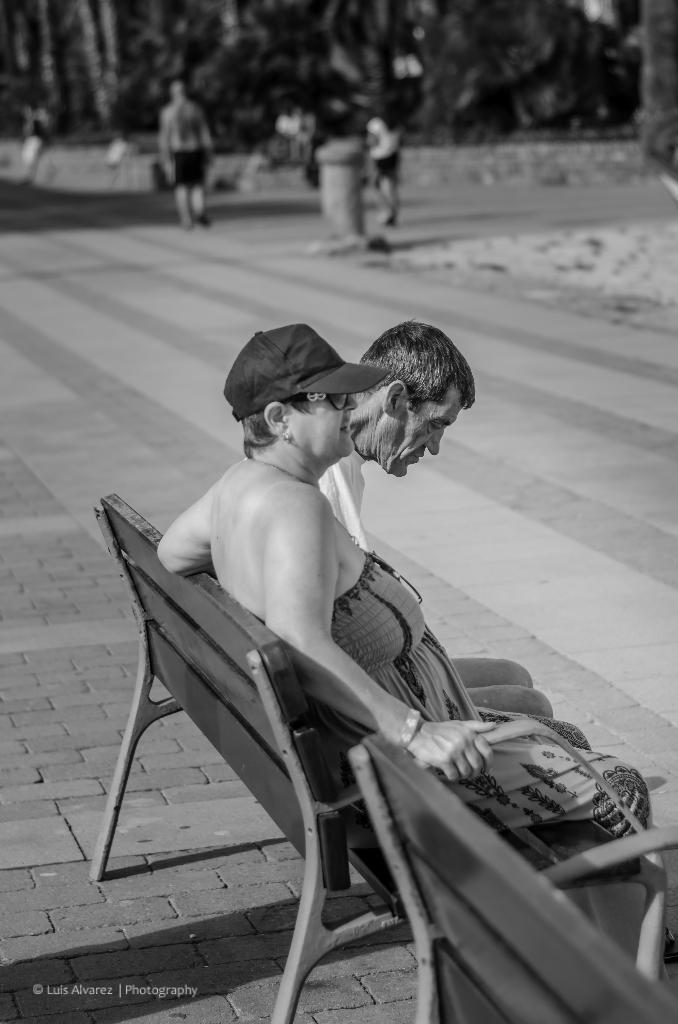Could you give a brief overview of what you see in this image? In this picture I can observe two members sitting on the bench. In the background there are some people and I can observe some trees. This is a black and white image. 